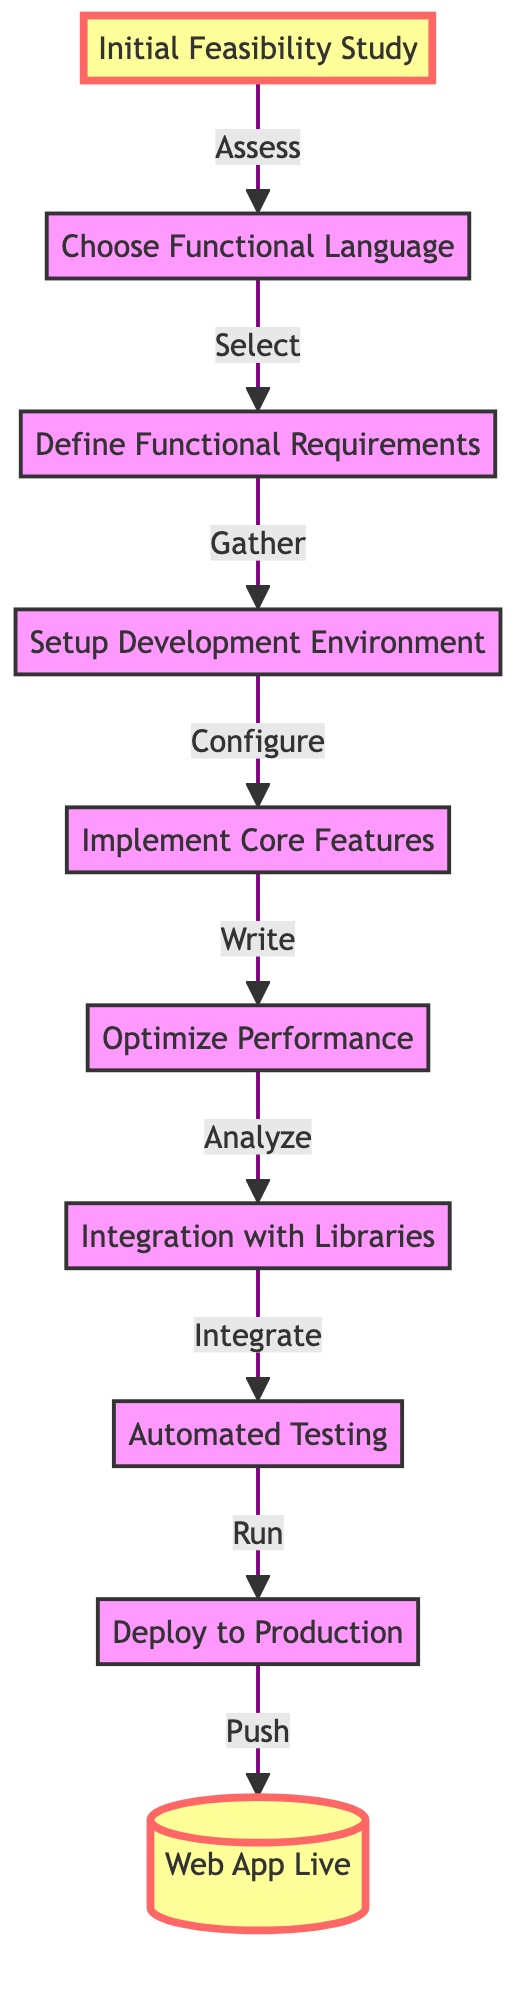What is the first step in the flow chart? The flow chart indicates that the first step is "Initial Feasibility Study," as it is the topmost node in the diagram.
Answer: Initial Feasibility Study How many nodes are present in the diagram? By counting each unique step in the flow chart, we can identify that there are a total of 10 nodes listed, including the final "Web App Live."
Answer: 10 What is the last action before deploying to production? The last action before "Deploy to Production" is "Automated Testing," which is directly connected to it in the flow.
Answer: Automated Testing Which step follows after "Integrate with Libraries"? The diagram shows that "Automated Testing" directly follows "Integrate with Libraries," as it flows from one step to the next.
Answer: Automated Testing What relationship exists between "Define Functional Requirements" and "Setup Development Environment"? "Setup Development Environment" is a direct subsequent step after "Define Functional Requirements," indicating a flow from requirement definition to tool setup.
Answer: Configure What step involves writing the core logic of the application? According to the flow, the step labeled "Implement Core Features" specifically refers to the action of writing the core logic.
Answer: Implement Core Features What is the relationship between "Choose Functional Language" and "Define Functional Requirements"? "Choose Functional Language" precedes "Define Functional Requirements" in the flow, indicating that selecting the language comes before gathering functional specifications.
Answer: Select How many steps are required from "Define Functional Requirements" to "Web App Live"? To reach "Web App Live" from "Define Functional Requirements," there are five steps: Define Functional Requirements, Setup Development Environment, Implement Core Features, Optimize Performance, and Integration with Libraries.
Answer: 5 What happens after the "Optimize Performance" step? The following step after "Optimize Performance" is "Integration with Libraries," further detailing the progression in the development process.
Answer: Integration with Libraries 